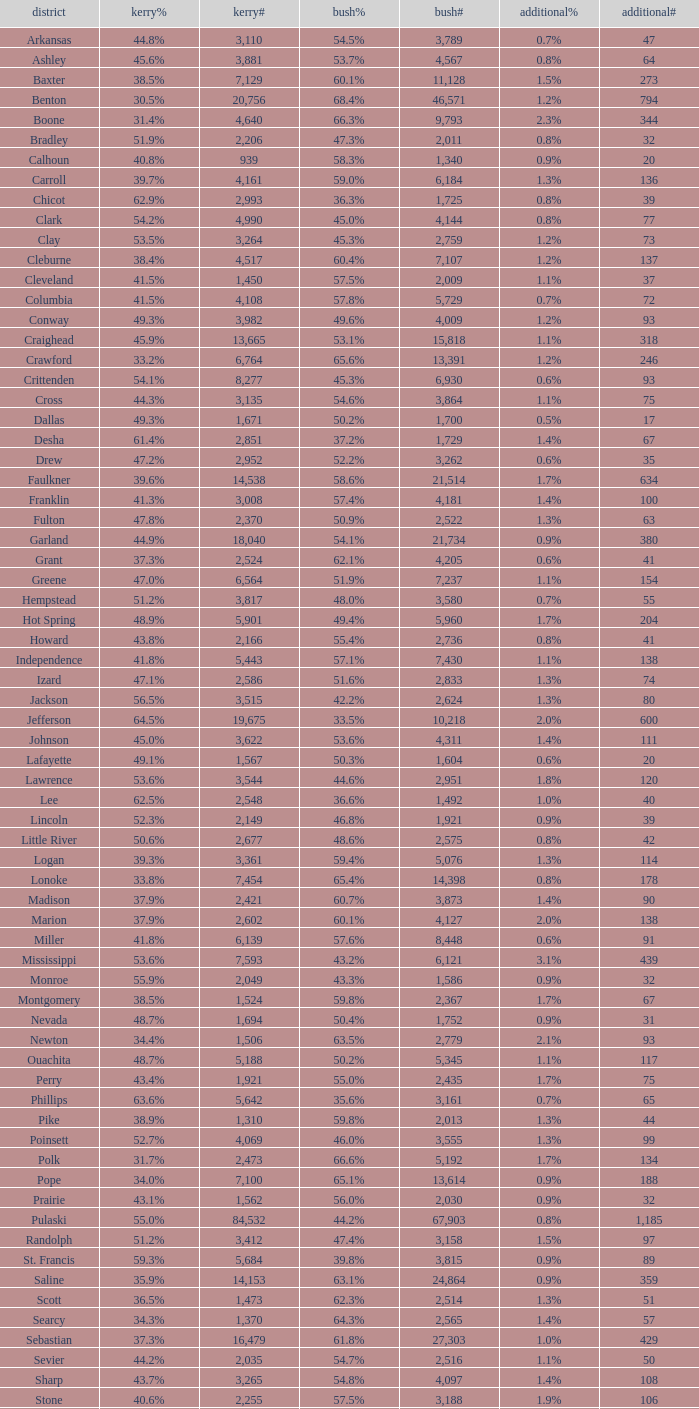I'm looking to parse the entire table for insights. Could you assist me with that? {'header': ['district', 'kerry%', 'kerry#', 'bush%', 'bush#', 'additional%', 'additional#'], 'rows': [['Arkansas', '44.8%', '3,110', '54.5%', '3,789', '0.7%', '47'], ['Ashley', '45.6%', '3,881', '53.7%', '4,567', '0.8%', '64'], ['Baxter', '38.5%', '7,129', '60.1%', '11,128', '1.5%', '273'], ['Benton', '30.5%', '20,756', '68.4%', '46,571', '1.2%', '794'], ['Boone', '31.4%', '4,640', '66.3%', '9,793', '2.3%', '344'], ['Bradley', '51.9%', '2,206', '47.3%', '2,011', '0.8%', '32'], ['Calhoun', '40.8%', '939', '58.3%', '1,340', '0.9%', '20'], ['Carroll', '39.7%', '4,161', '59.0%', '6,184', '1.3%', '136'], ['Chicot', '62.9%', '2,993', '36.3%', '1,725', '0.8%', '39'], ['Clark', '54.2%', '4,990', '45.0%', '4,144', '0.8%', '77'], ['Clay', '53.5%', '3,264', '45.3%', '2,759', '1.2%', '73'], ['Cleburne', '38.4%', '4,517', '60.4%', '7,107', '1.2%', '137'], ['Cleveland', '41.5%', '1,450', '57.5%', '2,009', '1.1%', '37'], ['Columbia', '41.5%', '4,108', '57.8%', '5,729', '0.7%', '72'], ['Conway', '49.3%', '3,982', '49.6%', '4,009', '1.2%', '93'], ['Craighead', '45.9%', '13,665', '53.1%', '15,818', '1.1%', '318'], ['Crawford', '33.2%', '6,764', '65.6%', '13,391', '1.2%', '246'], ['Crittenden', '54.1%', '8,277', '45.3%', '6,930', '0.6%', '93'], ['Cross', '44.3%', '3,135', '54.6%', '3,864', '1.1%', '75'], ['Dallas', '49.3%', '1,671', '50.2%', '1,700', '0.5%', '17'], ['Desha', '61.4%', '2,851', '37.2%', '1,729', '1.4%', '67'], ['Drew', '47.2%', '2,952', '52.2%', '3,262', '0.6%', '35'], ['Faulkner', '39.6%', '14,538', '58.6%', '21,514', '1.7%', '634'], ['Franklin', '41.3%', '3,008', '57.4%', '4,181', '1.4%', '100'], ['Fulton', '47.8%', '2,370', '50.9%', '2,522', '1.3%', '63'], ['Garland', '44.9%', '18,040', '54.1%', '21,734', '0.9%', '380'], ['Grant', '37.3%', '2,524', '62.1%', '4,205', '0.6%', '41'], ['Greene', '47.0%', '6,564', '51.9%', '7,237', '1.1%', '154'], ['Hempstead', '51.2%', '3,817', '48.0%', '3,580', '0.7%', '55'], ['Hot Spring', '48.9%', '5,901', '49.4%', '5,960', '1.7%', '204'], ['Howard', '43.8%', '2,166', '55.4%', '2,736', '0.8%', '41'], ['Independence', '41.8%', '5,443', '57.1%', '7,430', '1.1%', '138'], ['Izard', '47.1%', '2,586', '51.6%', '2,833', '1.3%', '74'], ['Jackson', '56.5%', '3,515', '42.2%', '2,624', '1.3%', '80'], ['Jefferson', '64.5%', '19,675', '33.5%', '10,218', '2.0%', '600'], ['Johnson', '45.0%', '3,622', '53.6%', '4,311', '1.4%', '111'], ['Lafayette', '49.1%', '1,567', '50.3%', '1,604', '0.6%', '20'], ['Lawrence', '53.6%', '3,544', '44.6%', '2,951', '1.8%', '120'], ['Lee', '62.5%', '2,548', '36.6%', '1,492', '1.0%', '40'], ['Lincoln', '52.3%', '2,149', '46.8%', '1,921', '0.9%', '39'], ['Little River', '50.6%', '2,677', '48.6%', '2,575', '0.8%', '42'], ['Logan', '39.3%', '3,361', '59.4%', '5,076', '1.3%', '114'], ['Lonoke', '33.8%', '7,454', '65.4%', '14,398', '0.8%', '178'], ['Madison', '37.9%', '2,421', '60.7%', '3,873', '1.4%', '90'], ['Marion', '37.9%', '2,602', '60.1%', '4,127', '2.0%', '138'], ['Miller', '41.8%', '6,139', '57.6%', '8,448', '0.6%', '91'], ['Mississippi', '53.6%', '7,593', '43.2%', '6,121', '3.1%', '439'], ['Monroe', '55.9%', '2,049', '43.3%', '1,586', '0.9%', '32'], ['Montgomery', '38.5%', '1,524', '59.8%', '2,367', '1.7%', '67'], ['Nevada', '48.7%', '1,694', '50.4%', '1,752', '0.9%', '31'], ['Newton', '34.4%', '1,506', '63.5%', '2,779', '2.1%', '93'], ['Ouachita', '48.7%', '5,188', '50.2%', '5,345', '1.1%', '117'], ['Perry', '43.4%', '1,921', '55.0%', '2,435', '1.7%', '75'], ['Phillips', '63.6%', '5,642', '35.6%', '3,161', '0.7%', '65'], ['Pike', '38.9%', '1,310', '59.8%', '2,013', '1.3%', '44'], ['Poinsett', '52.7%', '4,069', '46.0%', '3,555', '1.3%', '99'], ['Polk', '31.7%', '2,473', '66.6%', '5,192', '1.7%', '134'], ['Pope', '34.0%', '7,100', '65.1%', '13,614', '0.9%', '188'], ['Prairie', '43.1%', '1,562', '56.0%', '2,030', '0.9%', '32'], ['Pulaski', '55.0%', '84,532', '44.2%', '67,903', '0.8%', '1,185'], ['Randolph', '51.2%', '3,412', '47.4%', '3,158', '1.5%', '97'], ['St. Francis', '59.3%', '5,684', '39.8%', '3,815', '0.9%', '89'], ['Saline', '35.9%', '14,153', '63.1%', '24,864', '0.9%', '359'], ['Scott', '36.5%', '1,473', '62.3%', '2,514', '1.3%', '51'], ['Searcy', '34.3%', '1,370', '64.3%', '2,565', '1.4%', '57'], ['Sebastian', '37.3%', '16,479', '61.8%', '27,303', '1.0%', '429'], ['Sevier', '44.2%', '2,035', '54.7%', '2,516', '1.1%', '50'], ['Sharp', '43.7%', '3,265', '54.8%', '4,097', '1.4%', '108'], ['Stone', '40.6%', '2,255', '57.5%', '3,188', '1.9%', '106'], ['Union', '39.7%', '7,071', '58.9%', '10,502', '1.5%', '259'], ['Van Buren', '44.9%', '3,310', '54.1%', '3,988', '1.0%', '76'], ['Washington', '43.1%', '27,597', '55.7%', '35,726', '1.2%', '780'], ['White', '34.5%', '9,129', '64.3%', '17,001', '1.1%', '295'], ['Woodruff', '65.2%', '1,972', '33.7%', '1,021', '1.1%', '33'], ['Yell', '43.7%', '2,913', '55.2%', '3,678', '1.0%', '68']]} What is the highest Bush#, when Others% is "1.7%", when Others# is less than 75, and when Kerry# is greater than 1,524? None. 